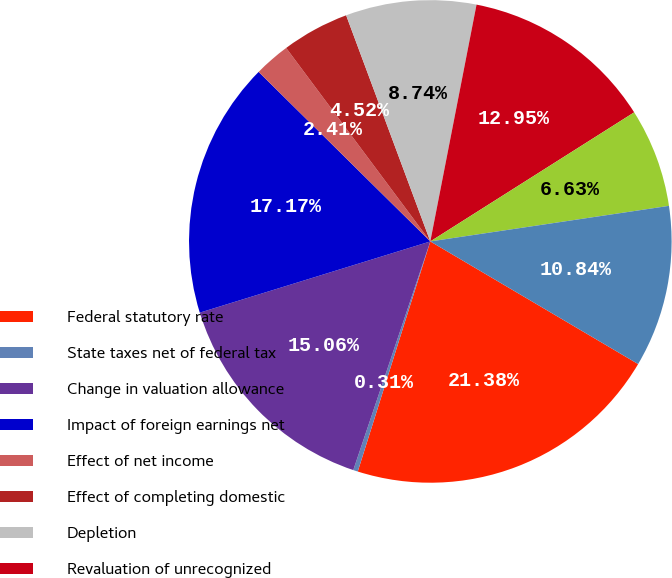Convert chart. <chart><loc_0><loc_0><loc_500><loc_500><pie_chart><fcel>Federal statutory rate<fcel>State taxes net of federal tax<fcel>Change in valuation allowance<fcel>Impact of foreign earnings net<fcel>Effect of net income<fcel>Effect of completing domestic<fcel>Depletion<fcel>Revaluation of unrecognized<fcel>Other items net<fcel>Effective income tax rate<nl><fcel>21.38%<fcel>0.31%<fcel>15.06%<fcel>17.17%<fcel>2.41%<fcel>4.52%<fcel>8.74%<fcel>12.95%<fcel>6.63%<fcel>10.84%<nl></chart> 